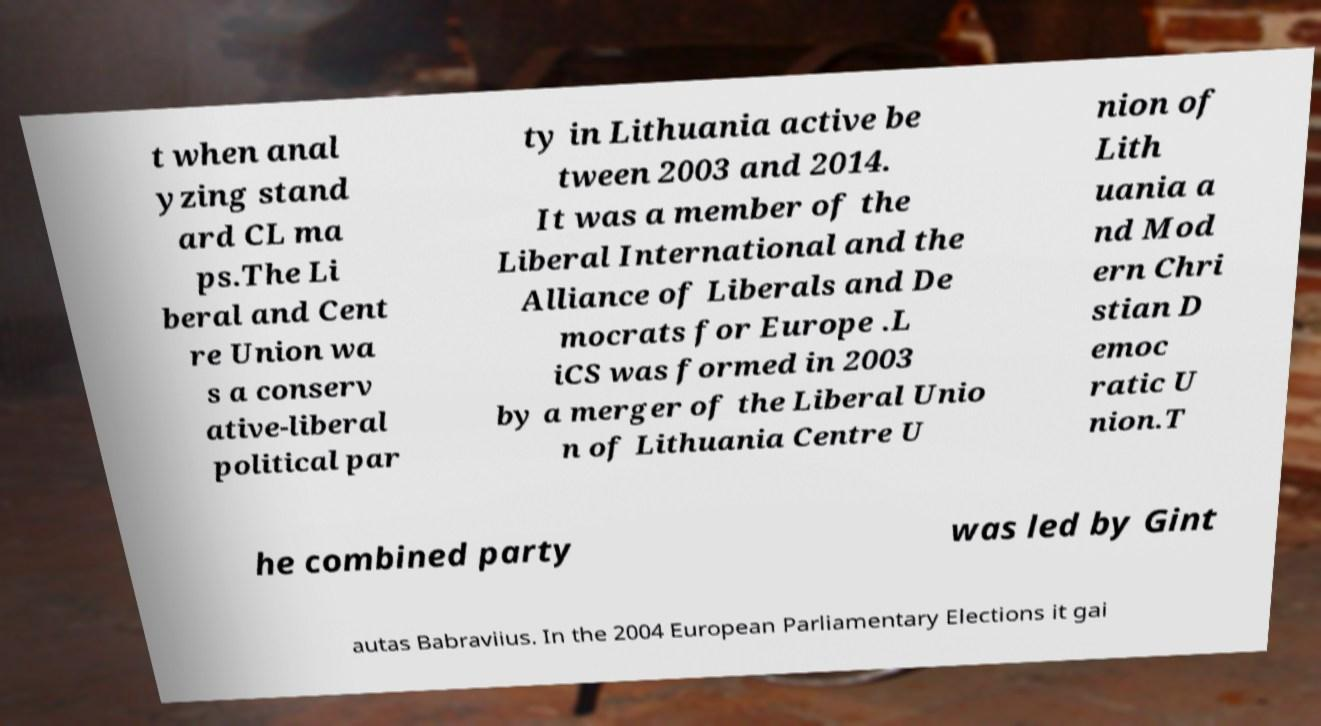Please read and relay the text visible in this image. What does it say? t when anal yzing stand ard CL ma ps.The Li beral and Cent re Union wa s a conserv ative-liberal political par ty in Lithuania active be tween 2003 and 2014. It was a member of the Liberal International and the Alliance of Liberals and De mocrats for Europe .L iCS was formed in 2003 by a merger of the Liberal Unio n of Lithuania Centre U nion of Lith uania a nd Mod ern Chri stian D emoc ratic U nion.T he combined party was led by Gint autas Babraviius. In the 2004 European Parliamentary Elections it gai 